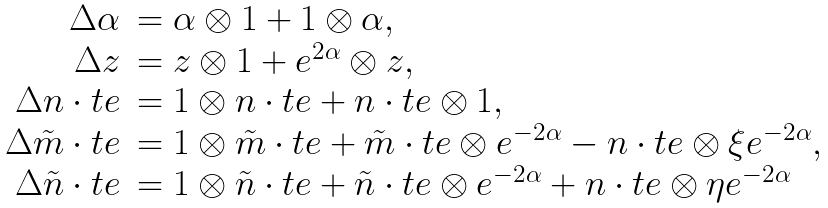Convert formula to latex. <formula><loc_0><loc_0><loc_500><loc_500>\begin{array} { r l } \Delta \alpha & = \alpha \otimes 1 + 1 \otimes \alpha , \\ \Delta z & = z \otimes 1 + e ^ { 2 \alpha } \otimes z , \\ \Delta n \cdot t e & = 1 \otimes n \cdot t e + n \cdot t e \otimes 1 , \\ \Delta \tilde { m } \cdot t e & = 1 \otimes \tilde { m } \cdot t e + \tilde { m } \cdot t e \otimes e ^ { - 2 \alpha } - n \cdot t e \otimes \xi e ^ { - 2 \alpha } , \\ \Delta \tilde { n } \cdot t e & = 1 \otimes \tilde { n } \cdot t e + \tilde { n } \cdot t e \otimes e ^ { - 2 \alpha } + n \cdot t e \otimes \eta e ^ { - 2 \alpha } \end{array}</formula> 